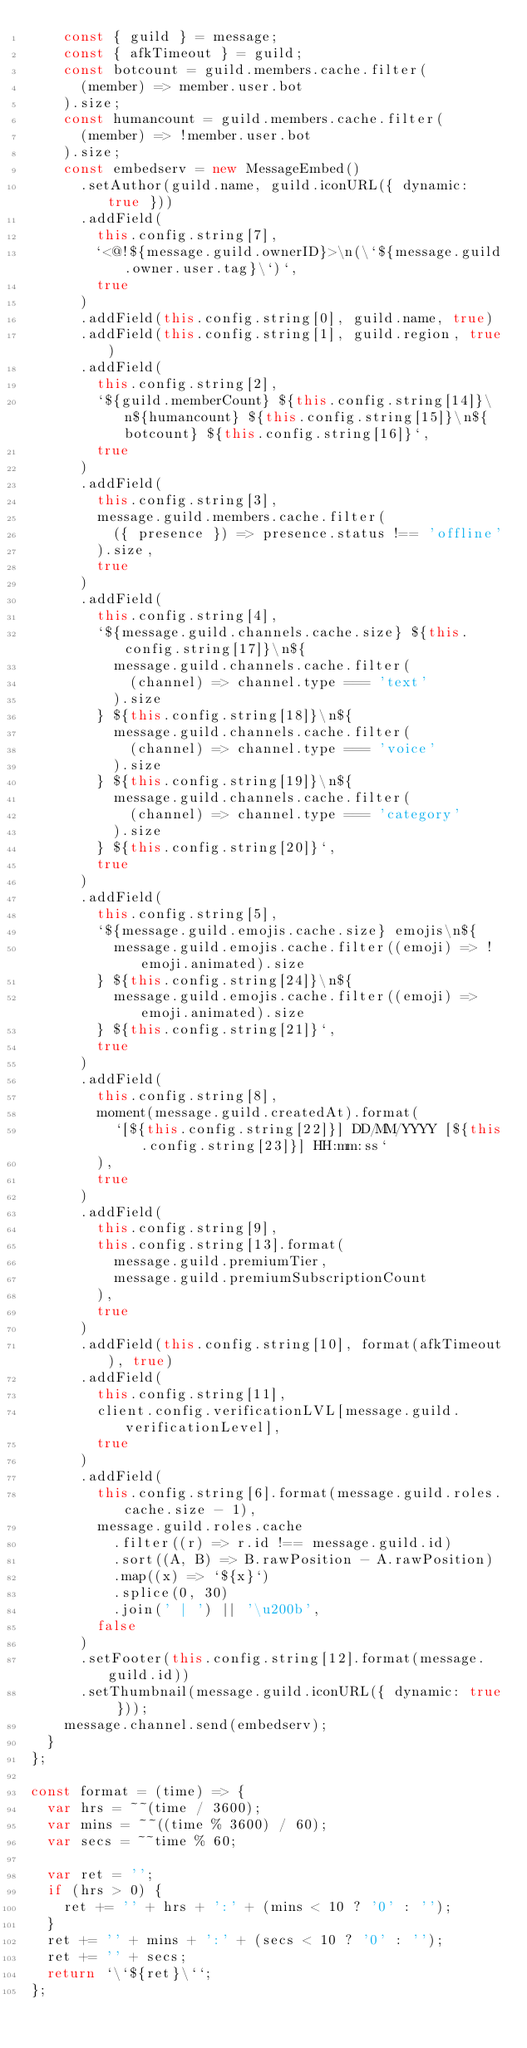Convert code to text. <code><loc_0><loc_0><loc_500><loc_500><_JavaScript_>    const { guild } = message;
    const { afkTimeout } = guild;
    const botcount = guild.members.cache.filter(
      (member) => member.user.bot
    ).size;
    const humancount = guild.members.cache.filter(
      (member) => !member.user.bot
    ).size;
    const embedserv = new MessageEmbed()
      .setAuthor(guild.name, guild.iconURL({ dynamic: true }))
      .addField(
        this.config.string[7],
        `<@!${message.guild.ownerID}>\n(\`${message.guild.owner.user.tag}\`)`,
        true
      )
      .addField(this.config.string[0], guild.name, true)
      .addField(this.config.string[1], guild.region, true)
      .addField(
        this.config.string[2],
        `${guild.memberCount} ${this.config.string[14]}\n${humancount} ${this.config.string[15]}\n${botcount} ${this.config.string[16]}`,
        true
      )
      .addField(
        this.config.string[3],
        message.guild.members.cache.filter(
          ({ presence }) => presence.status !== 'offline'
        ).size,
        true
      )
      .addField(
        this.config.string[4],
        `${message.guild.channels.cache.size} ${this.config.string[17]}\n${
          message.guild.channels.cache.filter(
            (channel) => channel.type === 'text'
          ).size
        } ${this.config.string[18]}\n${
          message.guild.channels.cache.filter(
            (channel) => channel.type === 'voice'
          ).size
        } ${this.config.string[19]}\n${
          message.guild.channels.cache.filter(
            (channel) => channel.type === 'category'
          ).size
        } ${this.config.string[20]}`,
        true
      )
      .addField(
        this.config.string[5],
        `${message.guild.emojis.cache.size} emojis\n${
          message.guild.emojis.cache.filter((emoji) => !emoji.animated).size
        } ${this.config.string[24]}\n${
          message.guild.emojis.cache.filter((emoji) => emoji.animated).size
        } ${this.config.string[21]}`,
        true
      )
      .addField(
        this.config.string[8],
        moment(message.guild.createdAt).format(
          `[${this.config.string[22]}] DD/MM/YYYY [${this.config.string[23]}] HH:mm:ss`
        ),
        true
      )
      .addField(
        this.config.string[9],
        this.config.string[13].format(
          message.guild.premiumTier,
          message.guild.premiumSubscriptionCount
        ),
        true
      )
      .addField(this.config.string[10], format(afkTimeout), true)
      .addField(
        this.config.string[11],
        client.config.verificationLVL[message.guild.verificationLevel],
        true
      )
      .addField(
        this.config.string[6].format(message.guild.roles.cache.size - 1),
        message.guild.roles.cache
          .filter((r) => r.id !== message.guild.id)
          .sort((A, B) => B.rawPosition - A.rawPosition)
          .map((x) => `${x}`)
          .splice(0, 30)
          .join(' | ') || '\u200b',
        false
      )
      .setFooter(this.config.string[12].format(message.guild.id))
      .setThumbnail(message.guild.iconURL({ dynamic: true }));
    message.channel.send(embedserv);
  }
};

const format = (time) => {
  var hrs = ~~(time / 3600);
  var mins = ~~((time % 3600) / 60);
  var secs = ~~time % 60;

  var ret = '';
  if (hrs > 0) {
    ret += '' + hrs + ':' + (mins < 10 ? '0' : '');
  }
  ret += '' + mins + ':' + (secs < 10 ? '0' : '');
  ret += '' + secs;
  return `\`${ret}\``;
};
</code> 